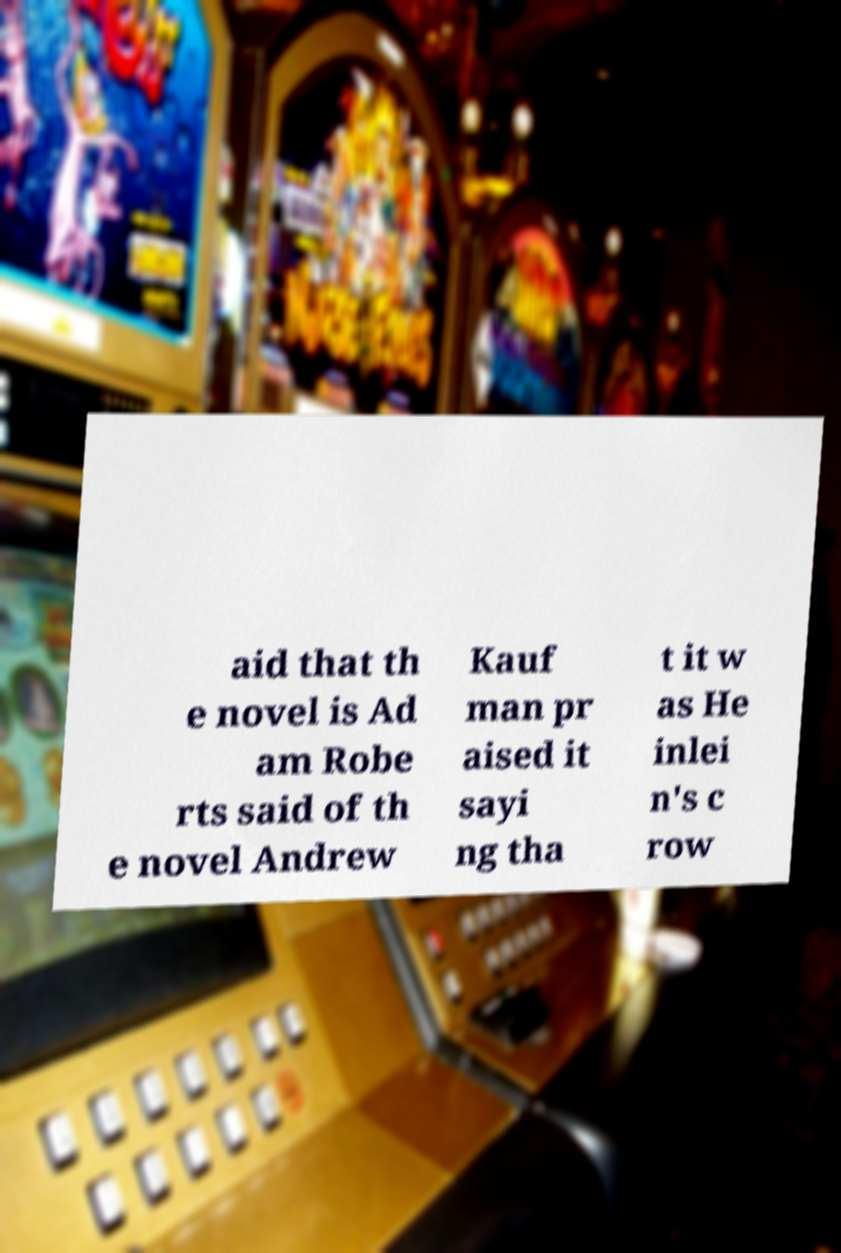Can you read and provide the text displayed in the image?This photo seems to have some interesting text. Can you extract and type it out for me? aid that th e novel is Ad am Robe rts said of th e novel Andrew Kauf man pr aised it sayi ng tha t it w as He inlei n's c row 